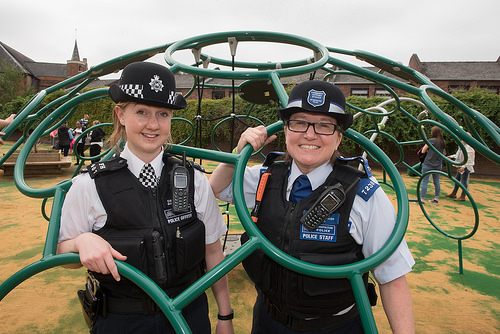<image>
Can you confirm if the woman is in the metal ring? Yes. The woman is contained within or inside the metal ring, showing a containment relationship. Is there a hat in the ring? No. The hat is not contained within the ring. These objects have a different spatial relationship. 